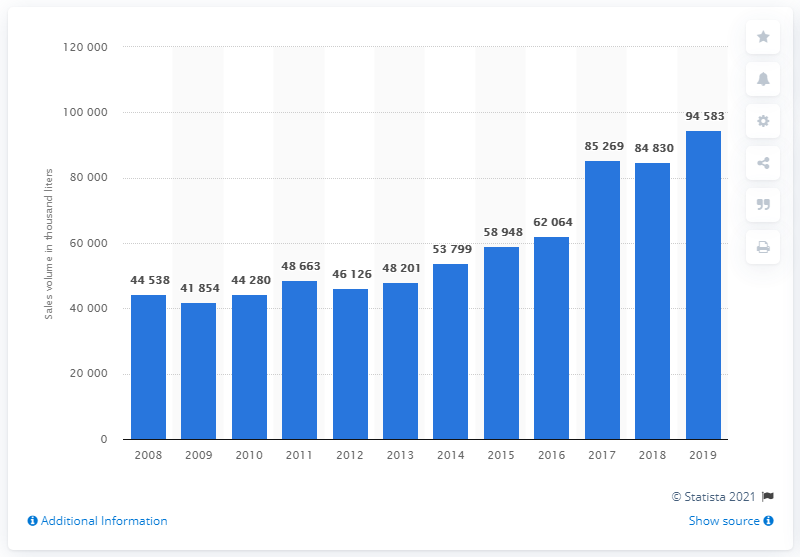Draw attention to some important aspects in this diagram. According to the sales data from 2019, the volume of gin and geneva sales was 94,583... 